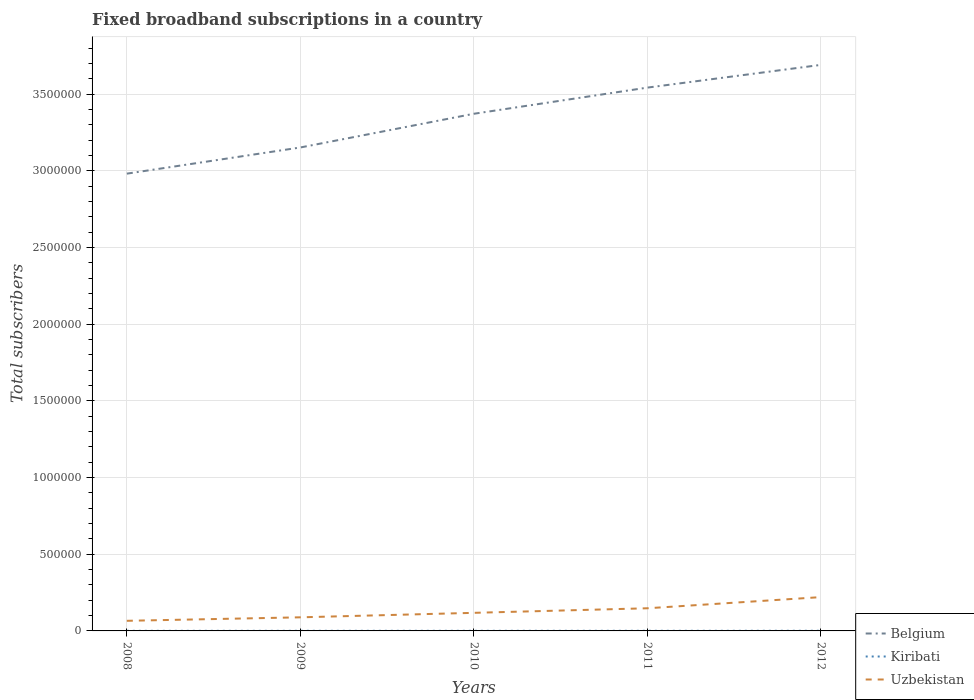How many different coloured lines are there?
Provide a succinct answer. 3. Is the number of lines equal to the number of legend labels?
Give a very brief answer. Yes. Across all years, what is the maximum number of broadband subscriptions in Kiribati?
Your answer should be compact. 685. What is the total number of broadband subscriptions in Belgium in the graph?
Provide a succinct answer. -2.20e+05. What is the difference between the highest and the second highest number of broadband subscriptions in Uzbekistan?
Your answer should be compact. 1.55e+05. How many lines are there?
Provide a short and direct response. 3. What is the difference between two consecutive major ticks on the Y-axis?
Ensure brevity in your answer.  5.00e+05. Are the values on the major ticks of Y-axis written in scientific E-notation?
Give a very brief answer. No. Does the graph contain any zero values?
Provide a succinct answer. No. Where does the legend appear in the graph?
Ensure brevity in your answer.  Bottom right. How are the legend labels stacked?
Offer a very short reply. Vertical. What is the title of the graph?
Your answer should be compact. Fixed broadband subscriptions in a country. Does "Cameroon" appear as one of the legend labels in the graph?
Make the answer very short. No. What is the label or title of the X-axis?
Make the answer very short. Years. What is the label or title of the Y-axis?
Your response must be concise. Total subscribers. What is the Total subscribers of Belgium in 2008?
Provide a short and direct response. 2.98e+06. What is the Total subscribers of Kiribati in 2008?
Your answer should be very brief. 685. What is the Total subscribers in Uzbekistan in 2008?
Your response must be concise. 6.60e+04. What is the Total subscribers of Belgium in 2009?
Provide a succinct answer. 3.15e+06. What is the Total subscribers of Kiribati in 2009?
Your response must be concise. 765. What is the Total subscribers in Uzbekistan in 2009?
Give a very brief answer. 8.87e+04. What is the Total subscribers of Belgium in 2010?
Your answer should be very brief. 3.37e+06. What is the Total subscribers in Kiribati in 2010?
Provide a short and direct response. 846. What is the Total subscribers of Uzbekistan in 2010?
Make the answer very short. 1.18e+05. What is the Total subscribers of Belgium in 2011?
Ensure brevity in your answer.  3.54e+06. What is the Total subscribers in Kiribati in 2011?
Your answer should be very brief. 920. What is the Total subscribers in Uzbekistan in 2011?
Offer a very short reply. 1.48e+05. What is the Total subscribers of Belgium in 2012?
Ensure brevity in your answer.  3.69e+06. What is the Total subscribers in Uzbekistan in 2012?
Offer a very short reply. 2.21e+05. Across all years, what is the maximum Total subscribers in Belgium?
Ensure brevity in your answer.  3.69e+06. Across all years, what is the maximum Total subscribers in Kiribati?
Your response must be concise. 1000. Across all years, what is the maximum Total subscribers of Uzbekistan?
Offer a terse response. 2.21e+05. Across all years, what is the minimum Total subscribers in Belgium?
Provide a succinct answer. 2.98e+06. Across all years, what is the minimum Total subscribers in Kiribati?
Offer a very short reply. 685. Across all years, what is the minimum Total subscribers of Uzbekistan?
Offer a very short reply. 6.60e+04. What is the total Total subscribers of Belgium in the graph?
Your response must be concise. 1.67e+07. What is the total Total subscribers in Kiribati in the graph?
Your response must be concise. 4216. What is the total Total subscribers of Uzbekistan in the graph?
Offer a terse response. 6.41e+05. What is the difference between the Total subscribers in Belgium in 2008 and that in 2009?
Ensure brevity in your answer.  -1.71e+05. What is the difference between the Total subscribers of Kiribati in 2008 and that in 2009?
Your response must be concise. -80. What is the difference between the Total subscribers in Uzbekistan in 2008 and that in 2009?
Give a very brief answer. -2.28e+04. What is the difference between the Total subscribers of Belgium in 2008 and that in 2010?
Your answer should be compact. -3.91e+05. What is the difference between the Total subscribers in Kiribati in 2008 and that in 2010?
Your answer should be compact. -161. What is the difference between the Total subscribers in Uzbekistan in 2008 and that in 2010?
Your response must be concise. -5.20e+04. What is the difference between the Total subscribers in Belgium in 2008 and that in 2011?
Make the answer very short. -5.61e+05. What is the difference between the Total subscribers in Kiribati in 2008 and that in 2011?
Make the answer very short. -235. What is the difference between the Total subscribers in Uzbekistan in 2008 and that in 2011?
Give a very brief answer. -8.18e+04. What is the difference between the Total subscribers in Belgium in 2008 and that in 2012?
Give a very brief answer. -7.10e+05. What is the difference between the Total subscribers of Kiribati in 2008 and that in 2012?
Offer a terse response. -315. What is the difference between the Total subscribers in Uzbekistan in 2008 and that in 2012?
Offer a very short reply. -1.55e+05. What is the difference between the Total subscribers in Belgium in 2009 and that in 2010?
Provide a short and direct response. -2.20e+05. What is the difference between the Total subscribers of Kiribati in 2009 and that in 2010?
Offer a terse response. -81. What is the difference between the Total subscribers in Uzbekistan in 2009 and that in 2010?
Keep it short and to the point. -2.93e+04. What is the difference between the Total subscribers of Belgium in 2009 and that in 2011?
Provide a succinct answer. -3.90e+05. What is the difference between the Total subscribers in Kiribati in 2009 and that in 2011?
Provide a short and direct response. -155. What is the difference between the Total subscribers in Uzbekistan in 2009 and that in 2011?
Your answer should be very brief. -5.90e+04. What is the difference between the Total subscribers of Belgium in 2009 and that in 2012?
Your answer should be compact. -5.39e+05. What is the difference between the Total subscribers of Kiribati in 2009 and that in 2012?
Keep it short and to the point. -235. What is the difference between the Total subscribers of Uzbekistan in 2009 and that in 2012?
Provide a short and direct response. -1.32e+05. What is the difference between the Total subscribers in Belgium in 2010 and that in 2011?
Keep it short and to the point. -1.71e+05. What is the difference between the Total subscribers of Kiribati in 2010 and that in 2011?
Offer a very short reply. -74. What is the difference between the Total subscribers of Uzbekistan in 2010 and that in 2011?
Offer a very short reply. -2.98e+04. What is the difference between the Total subscribers in Belgium in 2010 and that in 2012?
Ensure brevity in your answer.  -3.19e+05. What is the difference between the Total subscribers of Kiribati in 2010 and that in 2012?
Your answer should be very brief. -154. What is the difference between the Total subscribers in Uzbekistan in 2010 and that in 2012?
Offer a terse response. -1.03e+05. What is the difference between the Total subscribers in Belgium in 2011 and that in 2012?
Provide a succinct answer. -1.48e+05. What is the difference between the Total subscribers of Kiribati in 2011 and that in 2012?
Your answer should be very brief. -80. What is the difference between the Total subscribers of Uzbekistan in 2011 and that in 2012?
Provide a succinct answer. -7.28e+04. What is the difference between the Total subscribers of Belgium in 2008 and the Total subscribers of Kiribati in 2009?
Offer a very short reply. 2.98e+06. What is the difference between the Total subscribers in Belgium in 2008 and the Total subscribers in Uzbekistan in 2009?
Offer a terse response. 2.89e+06. What is the difference between the Total subscribers of Kiribati in 2008 and the Total subscribers of Uzbekistan in 2009?
Your response must be concise. -8.80e+04. What is the difference between the Total subscribers in Belgium in 2008 and the Total subscribers in Kiribati in 2010?
Provide a short and direct response. 2.98e+06. What is the difference between the Total subscribers in Belgium in 2008 and the Total subscribers in Uzbekistan in 2010?
Offer a terse response. 2.86e+06. What is the difference between the Total subscribers of Kiribati in 2008 and the Total subscribers of Uzbekistan in 2010?
Your answer should be very brief. -1.17e+05. What is the difference between the Total subscribers of Belgium in 2008 and the Total subscribers of Kiribati in 2011?
Offer a terse response. 2.98e+06. What is the difference between the Total subscribers in Belgium in 2008 and the Total subscribers in Uzbekistan in 2011?
Your response must be concise. 2.83e+06. What is the difference between the Total subscribers in Kiribati in 2008 and the Total subscribers in Uzbekistan in 2011?
Provide a short and direct response. -1.47e+05. What is the difference between the Total subscribers of Belgium in 2008 and the Total subscribers of Kiribati in 2012?
Keep it short and to the point. 2.98e+06. What is the difference between the Total subscribers in Belgium in 2008 and the Total subscribers in Uzbekistan in 2012?
Ensure brevity in your answer.  2.76e+06. What is the difference between the Total subscribers in Kiribati in 2008 and the Total subscribers in Uzbekistan in 2012?
Your answer should be very brief. -2.20e+05. What is the difference between the Total subscribers in Belgium in 2009 and the Total subscribers in Kiribati in 2010?
Your answer should be very brief. 3.15e+06. What is the difference between the Total subscribers in Belgium in 2009 and the Total subscribers in Uzbekistan in 2010?
Your answer should be compact. 3.04e+06. What is the difference between the Total subscribers of Kiribati in 2009 and the Total subscribers of Uzbekistan in 2010?
Your answer should be very brief. -1.17e+05. What is the difference between the Total subscribers of Belgium in 2009 and the Total subscribers of Kiribati in 2011?
Provide a succinct answer. 3.15e+06. What is the difference between the Total subscribers of Belgium in 2009 and the Total subscribers of Uzbekistan in 2011?
Ensure brevity in your answer.  3.01e+06. What is the difference between the Total subscribers in Kiribati in 2009 and the Total subscribers in Uzbekistan in 2011?
Give a very brief answer. -1.47e+05. What is the difference between the Total subscribers in Belgium in 2009 and the Total subscribers in Kiribati in 2012?
Offer a very short reply. 3.15e+06. What is the difference between the Total subscribers in Belgium in 2009 and the Total subscribers in Uzbekistan in 2012?
Make the answer very short. 2.93e+06. What is the difference between the Total subscribers of Kiribati in 2009 and the Total subscribers of Uzbekistan in 2012?
Keep it short and to the point. -2.20e+05. What is the difference between the Total subscribers in Belgium in 2010 and the Total subscribers in Kiribati in 2011?
Your response must be concise. 3.37e+06. What is the difference between the Total subscribers of Belgium in 2010 and the Total subscribers of Uzbekistan in 2011?
Give a very brief answer. 3.23e+06. What is the difference between the Total subscribers of Kiribati in 2010 and the Total subscribers of Uzbekistan in 2011?
Make the answer very short. -1.47e+05. What is the difference between the Total subscribers in Belgium in 2010 and the Total subscribers in Kiribati in 2012?
Your answer should be compact. 3.37e+06. What is the difference between the Total subscribers in Belgium in 2010 and the Total subscribers in Uzbekistan in 2012?
Make the answer very short. 3.15e+06. What is the difference between the Total subscribers in Kiribati in 2010 and the Total subscribers in Uzbekistan in 2012?
Keep it short and to the point. -2.20e+05. What is the difference between the Total subscribers of Belgium in 2011 and the Total subscribers of Kiribati in 2012?
Give a very brief answer. 3.54e+06. What is the difference between the Total subscribers of Belgium in 2011 and the Total subscribers of Uzbekistan in 2012?
Provide a short and direct response. 3.32e+06. What is the difference between the Total subscribers of Kiribati in 2011 and the Total subscribers of Uzbekistan in 2012?
Your answer should be very brief. -2.20e+05. What is the average Total subscribers in Belgium per year?
Give a very brief answer. 3.35e+06. What is the average Total subscribers of Kiribati per year?
Make the answer very short. 843.2. What is the average Total subscribers of Uzbekistan per year?
Your answer should be very brief. 1.28e+05. In the year 2008, what is the difference between the Total subscribers in Belgium and Total subscribers in Kiribati?
Keep it short and to the point. 2.98e+06. In the year 2008, what is the difference between the Total subscribers in Belgium and Total subscribers in Uzbekistan?
Offer a terse response. 2.92e+06. In the year 2008, what is the difference between the Total subscribers in Kiribati and Total subscribers in Uzbekistan?
Offer a very short reply. -6.53e+04. In the year 2009, what is the difference between the Total subscribers of Belgium and Total subscribers of Kiribati?
Provide a succinct answer. 3.15e+06. In the year 2009, what is the difference between the Total subscribers in Belgium and Total subscribers in Uzbekistan?
Your answer should be compact. 3.06e+06. In the year 2009, what is the difference between the Total subscribers of Kiribati and Total subscribers of Uzbekistan?
Provide a short and direct response. -8.80e+04. In the year 2010, what is the difference between the Total subscribers of Belgium and Total subscribers of Kiribati?
Provide a short and direct response. 3.37e+06. In the year 2010, what is the difference between the Total subscribers in Belgium and Total subscribers in Uzbekistan?
Provide a short and direct response. 3.26e+06. In the year 2010, what is the difference between the Total subscribers of Kiribati and Total subscribers of Uzbekistan?
Provide a short and direct response. -1.17e+05. In the year 2011, what is the difference between the Total subscribers of Belgium and Total subscribers of Kiribati?
Your answer should be compact. 3.54e+06. In the year 2011, what is the difference between the Total subscribers of Belgium and Total subscribers of Uzbekistan?
Give a very brief answer. 3.40e+06. In the year 2011, what is the difference between the Total subscribers in Kiribati and Total subscribers in Uzbekistan?
Provide a short and direct response. -1.47e+05. In the year 2012, what is the difference between the Total subscribers of Belgium and Total subscribers of Kiribati?
Ensure brevity in your answer.  3.69e+06. In the year 2012, what is the difference between the Total subscribers in Belgium and Total subscribers in Uzbekistan?
Give a very brief answer. 3.47e+06. In the year 2012, what is the difference between the Total subscribers in Kiribati and Total subscribers in Uzbekistan?
Your answer should be compact. -2.20e+05. What is the ratio of the Total subscribers of Belgium in 2008 to that in 2009?
Your answer should be very brief. 0.95. What is the ratio of the Total subscribers in Kiribati in 2008 to that in 2009?
Provide a succinct answer. 0.9. What is the ratio of the Total subscribers of Uzbekistan in 2008 to that in 2009?
Make the answer very short. 0.74. What is the ratio of the Total subscribers in Belgium in 2008 to that in 2010?
Offer a very short reply. 0.88. What is the ratio of the Total subscribers of Kiribati in 2008 to that in 2010?
Offer a very short reply. 0.81. What is the ratio of the Total subscribers of Uzbekistan in 2008 to that in 2010?
Make the answer very short. 0.56. What is the ratio of the Total subscribers in Belgium in 2008 to that in 2011?
Your response must be concise. 0.84. What is the ratio of the Total subscribers in Kiribati in 2008 to that in 2011?
Make the answer very short. 0.74. What is the ratio of the Total subscribers of Uzbekistan in 2008 to that in 2011?
Ensure brevity in your answer.  0.45. What is the ratio of the Total subscribers of Belgium in 2008 to that in 2012?
Offer a terse response. 0.81. What is the ratio of the Total subscribers of Kiribati in 2008 to that in 2012?
Keep it short and to the point. 0.69. What is the ratio of the Total subscribers in Uzbekistan in 2008 to that in 2012?
Give a very brief answer. 0.3. What is the ratio of the Total subscribers of Belgium in 2009 to that in 2010?
Give a very brief answer. 0.93. What is the ratio of the Total subscribers in Kiribati in 2009 to that in 2010?
Provide a succinct answer. 0.9. What is the ratio of the Total subscribers of Uzbekistan in 2009 to that in 2010?
Provide a short and direct response. 0.75. What is the ratio of the Total subscribers of Belgium in 2009 to that in 2011?
Your response must be concise. 0.89. What is the ratio of the Total subscribers in Kiribati in 2009 to that in 2011?
Your response must be concise. 0.83. What is the ratio of the Total subscribers in Uzbekistan in 2009 to that in 2011?
Ensure brevity in your answer.  0.6. What is the ratio of the Total subscribers of Belgium in 2009 to that in 2012?
Keep it short and to the point. 0.85. What is the ratio of the Total subscribers in Kiribati in 2009 to that in 2012?
Give a very brief answer. 0.77. What is the ratio of the Total subscribers of Uzbekistan in 2009 to that in 2012?
Offer a terse response. 0.4. What is the ratio of the Total subscribers of Belgium in 2010 to that in 2011?
Ensure brevity in your answer.  0.95. What is the ratio of the Total subscribers in Kiribati in 2010 to that in 2011?
Provide a succinct answer. 0.92. What is the ratio of the Total subscribers in Uzbekistan in 2010 to that in 2011?
Offer a very short reply. 0.8. What is the ratio of the Total subscribers of Belgium in 2010 to that in 2012?
Your answer should be compact. 0.91. What is the ratio of the Total subscribers in Kiribati in 2010 to that in 2012?
Provide a short and direct response. 0.85. What is the ratio of the Total subscribers of Uzbekistan in 2010 to that in 2012?
Provide a succinct answer. 0.54. What is the ratio of the Total subscribers of Belgium in 2011 to that in 2012?
Keep it short and to the point. 0.96. What is the ratio of the Total subscribers of Uzbekistan in 2011 to that in 2012?
Give a very brief answer. 0.67. What is the difference between the highest and the second highest Total subscribers in Belgium?
Provide a short and direct response. 1.48e+05. What is the difference between the highest and the second highest Total subscribers in Uzbekistan?
Ensure brevity in your answer.  7.28e+04. What is the difference between the highest and the lowest Total subscribers of Belgium?
Provide a succinct answer. 7.10e+05. What is the difference between the highest and the lowest Total subscribers in Kiribati?
Provide a short and direct response. 315. What is the difference between the highest and the lowest Total subscribers in Uzbekistan?
Your response must be concise. 1.55e+05. 